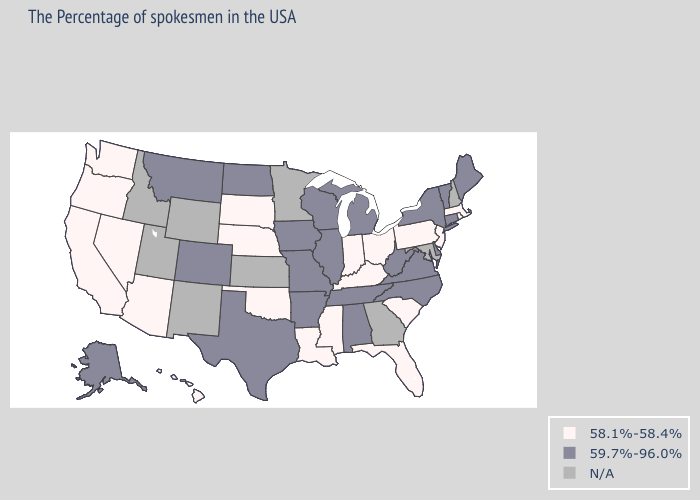What is the highest value in the South ?
Write a very short answer. 59.7%-96.0%. Name the states that have a value in the range 59.7%-96.0%?
Answer briefly. Maine, Vermont, Connecticut, New York, Delaware, Virginia, North Carolina, West Virginia, Michigan, Alabama, Tennessee, Wisconsin, Illinois, Missouri, Arkansas, Iowa, Texas, North Dakota, Colorado, Montana, Alaska. What is the value of North Dakota?
Write a very short answer. 59.7%-96.0%. What is the lowest value in states that border Nevada?
Give a very brief answer. 58.1%-58.4%. What is the value of Kentucky?
Concise answer only. 58.1%-58.4%. Which states have the lowest value in the South?
Keep it brief. South Carolina, Florida, Kentucky, Mississippi, Louisiana, Oklahoma. Name the states that have a value in the range 58.1%-58.4%?
Be succinct. Massachusetts, Rhode Island, New Jersey, Pennsylvania, South Carolina, Ohio, Florida, Kentucky, Indiana, Mississippi, Louisiana, Nebraska, Oklahoma, South Dakota, Arizona, Nevada, California, Washington, Oregon, Hawaii. What is the value of Utah?
Keep it brief. N/A. Name the states that have a value in the range N/A?
Short answer required. New Hampshire, Maryland, Georgia, Minnesota, Kansas, Wyoming, New Mexico, Utah, Idaho. What is the lowest value in the USA?
Answer briefly. 58.1%-58.4%. Does Iowa have the highest value in the USA?
Keep it brief. Yes. What is the highest value in the USA?
Write a very short answer. 59.7%-96.0%. What is the value of Hawaii?
Answer briefly. 58.1%-58.4%. What is the value of Michigan?
Write a very short answer. 59.7%-96.0%. 